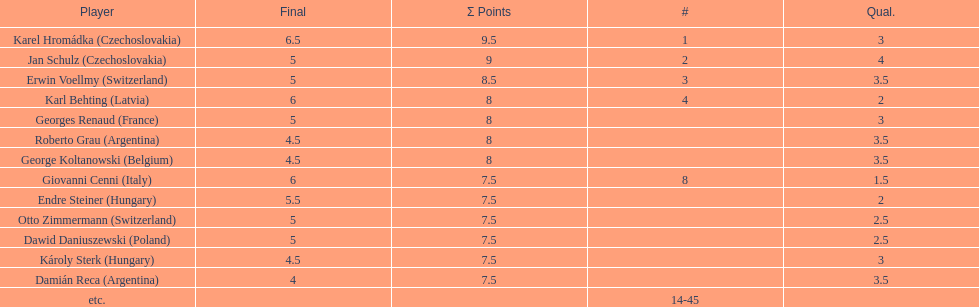How many players had a 8 points? 4. Help me parse the entirety of this table. {'header': ['Player', 'Final', 'Σ Points', '#', 'Qual.'], 'rows': [['Karel Hromádka\xa0(Czechoslovakia)', '6.5', '9.5', '1', '3'], ['Jan Schulz\xa0(Czechoslovakia)', '5', '9', '2', '4'], ['Erwin Voellmy\xa0(Switzerland)', '5', '8.5', '3', '3.5'], ['Karl Behting\xa0(Latvia)', '6', '8', '4', '2'], ['Georges Renaud\xa0(France)', '5', '8', '', '3'], ['Roberto Grau\xa0(Argentina)', '4.5', '8', '', '3.5'], ['George Koltanowski\xa0(Belgium)', '4.5', '8', '', '3.5'], ['Giovanni Cenni\xa0(Italy)', '6', '7.5', '8', '1.5'], ['Endre Steiner\xa0(Hungary)', '5.5', '7.5', '', '2'], ['Otto Zimmermann\xa0(Switzerland)', '5', '7.5', '', '2.5'], ['Dawid Daniuszewski\xa0(Poland)', '5', '7.5', '', '2.5'], ['Károly Sterk\xa0(Hungary)', '4.5', '7.5', '', '3'], ['Damián Reca\xa0(Argentina)', '4', '7.5', '', '3.5'], ['etc.', '', '', '14-45', '']]} 